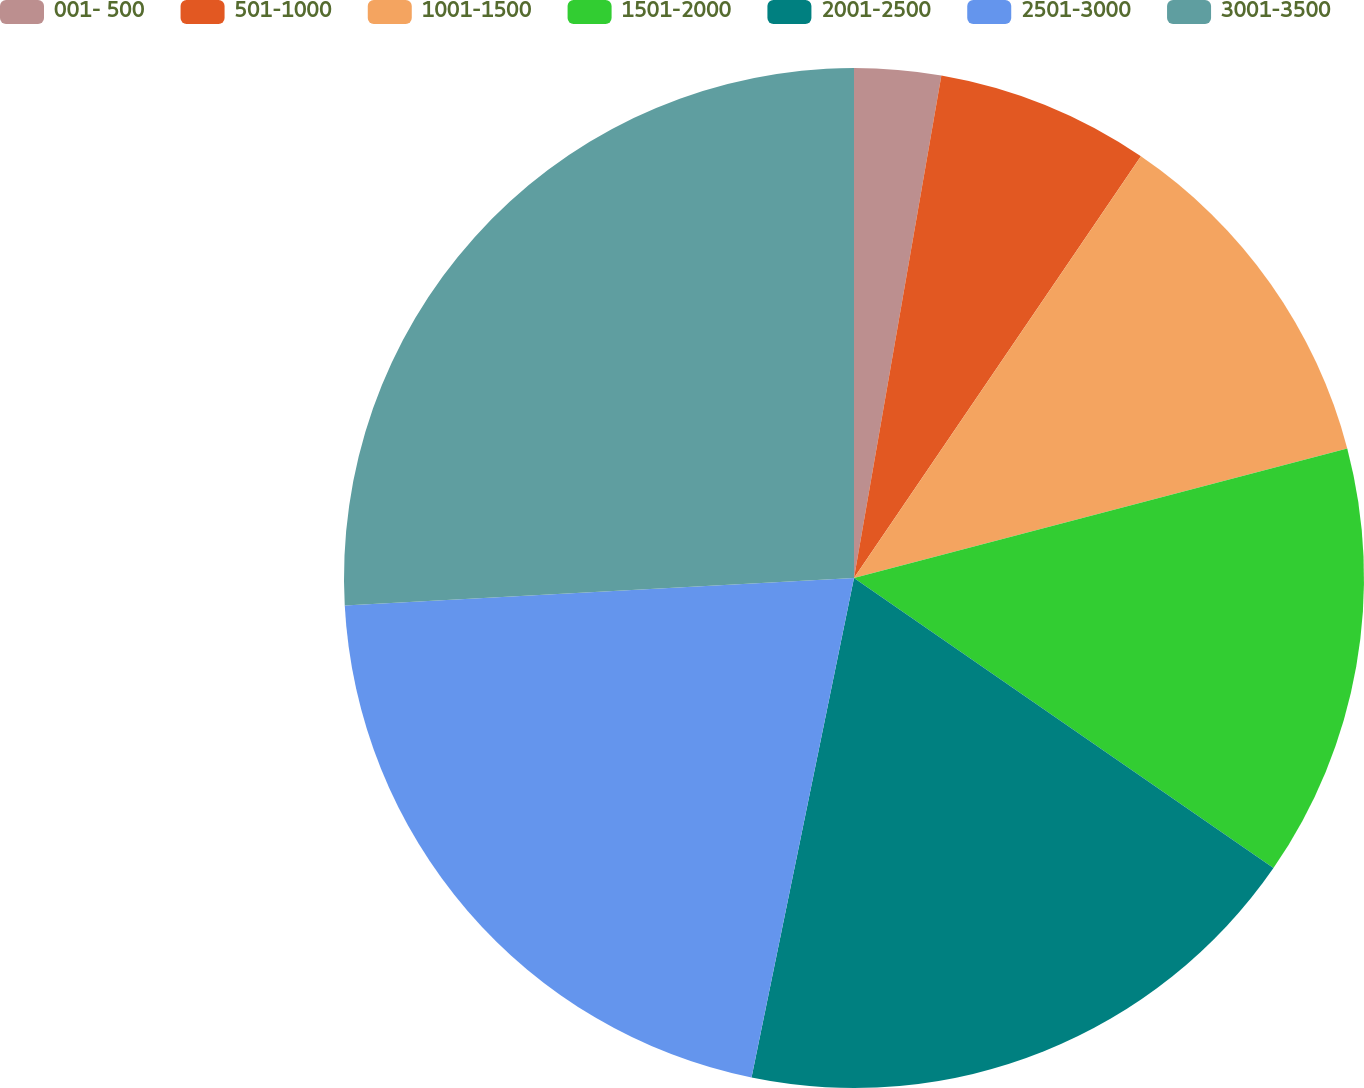Convert chart. <chart><loc_0><loc_0><loc_500><loc_500><pie_chart><fcel>001- 500<fcel>501-1000<fcel>1001-1500<fcel>1501-2000<fcel>2001-2500<fcel>2501-3000<fcel>3001-3500<nl><fcel>2.74%<fcel>6.77%<fcel>11.4%<fcel>13.72%<fcel>18.59%<fcel>20.92%<fcel>25.86%<nl></chart> 